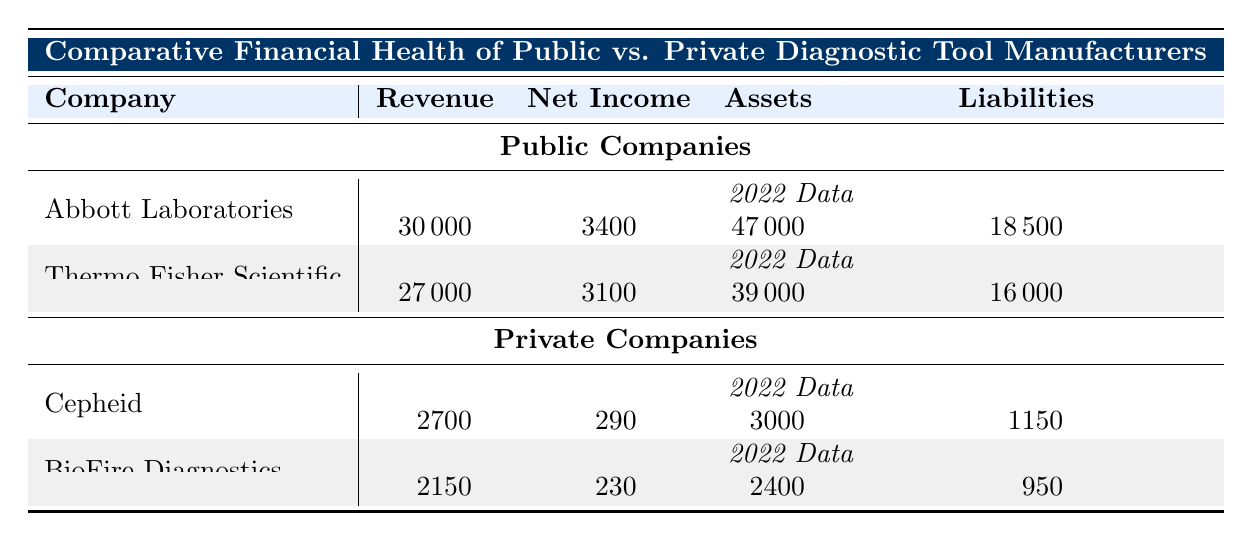What was the revenue of Abbott Laboratories in 2022? In the table, under the “Public Companies” section for Abbott Laboratories, the revenue for the year 2022 is listed as 30000.
Answer: 30000 What is the net income of Thermo Fisher Scientific for the year 2022? According to the table, the net income for Thermo Fisher Scientific in 2022 is stated as 3100.
Answer: 3100 Which company had the highest revenue in 2022? By comparing the revenues of Abbott Laboratories (30000) and Thermo Fisher Scientific (27000) in the public section and Cepheid (2700) and BioFire Diagnostics (2150) in the private section, Abbott Laboratories has the highest revenue in 2022.
Answer: Abbott Laboratories Is the total net income of private companies in 2022 greater than the total net income of public companies in the same year? The total net income of private companies is 290 (Cepheid) + 230 (BioFire Diagnostics) = 520. The total net income of public companies is 3400 (Abbott Laboratories) + 3100 (Thermo Fisher Scientific) = 6500. Since 520 is less than 6500, the net income of private companies is not greater than that of public companies.
Answer: No What is the average revenue of public companies in 2022? The revenues of public companies in 2022 are 30000 (Abbott Laboratories) and 27000 (Thermo Fisher Scientific). To find the average, sum the revenues (30000 + 27000) = 57000 and divide by the number of companies (2), which gives 57000 / 2 = 28500.
Answer: 28500 Did both private companies report a revenue increase from the previous year (2021)? For Cepheid, the revenue in 2021 is 2550 and in 2022 it is 2700, which is an increase. For BioFire Diagnostics, the revenue in 2021 is 2000 and in 2022 it is 2150, which is also an increase. Therefore, both companies saw a revenue increase.
Answer: Yes What is the total asset value for public companies compared to private companies in 2022? The total assets for public companies are 47000 (Abbott Laboratories) + 39000 (Thermo Fisher Scientific) = 86000. The total assets for private companies are 3000 (Cepheid) + 2400 (BioFire Diagnostics) = 5400. 86000 is significantly greater than 5400, showing a large difference in asset value.
Answer: 86000 vs. 5400 Which company had the lowest liabilities in 2022? In the table, the liabilities for Abbott Laboratories are 18500, for Thermo Fisher Scientific it is 16000, for Cepheid it is 1150, and for BioFire Diagnostics it is 950. Thus, BioFire Diagnostics has the lowest liabilities.
Answer: BioFire Diagnostics 